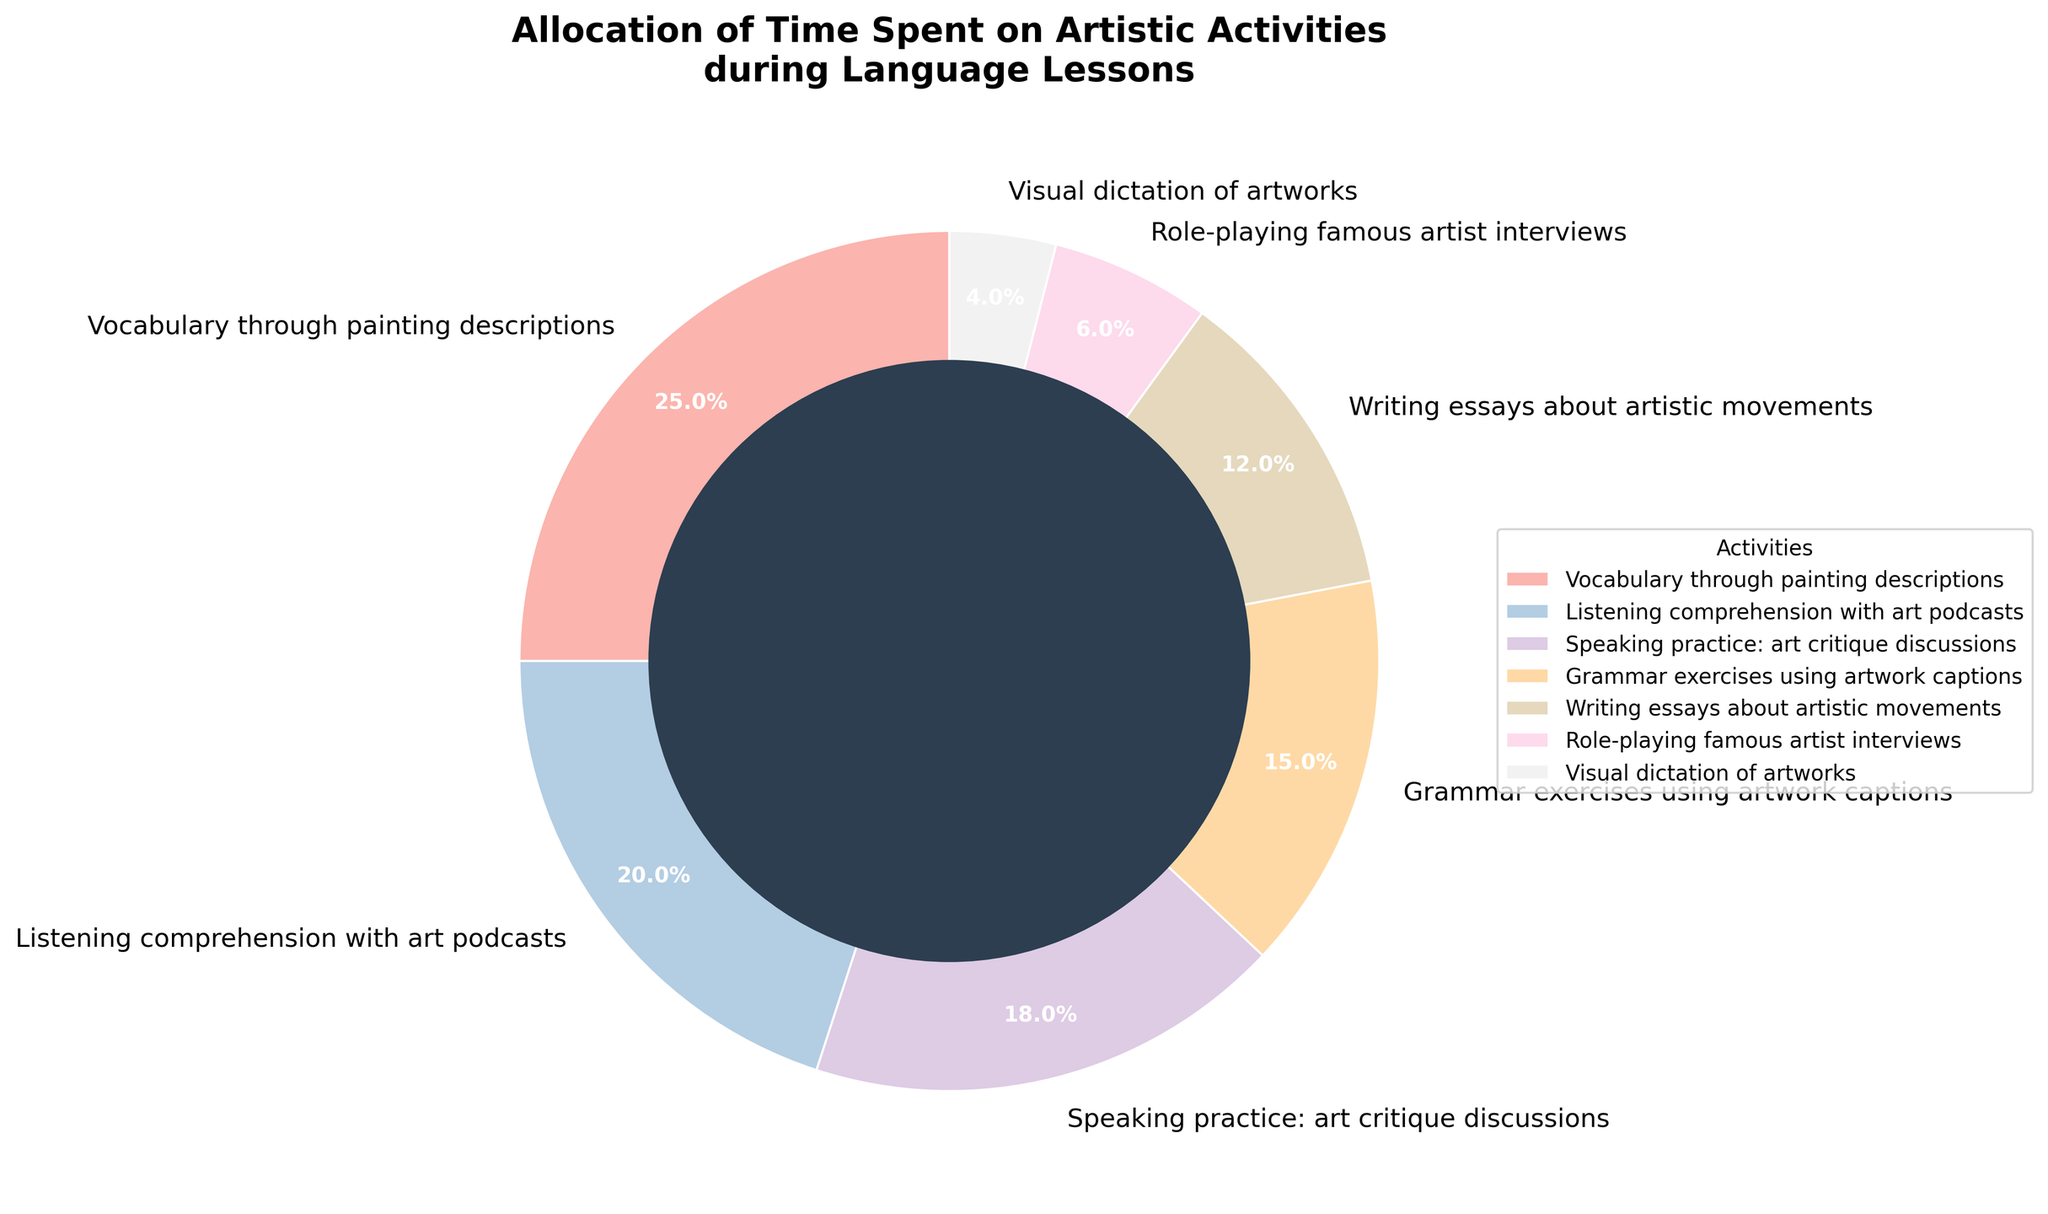What's the sum of time allocated to "Vocabulary through painting descriptions" and "Listening comprehension with art podcasts"? The time for "Vocabulary through painting descriptions" is 25%, and for "Listening comprehension with art podcasts" is 20%. Summing these two percentages: 25% + 20% = 45%
Answer: 45% Which activity has the least amount of time allocated, and what is its percentage? The activity with the smallest percentage is "Visual dictation of artworks," which has 4% time allocation as shown on the figure.
Answer: Visual dictation of artworks, 4% What is the difference in the time allocated between "Speaking practice: art critique discussions" and "Writing essays about artistic movements"? Time allocated to "Speaking practice: art critique discussions" is 18% and "Writing essays about artistic movements" is 12%. The difference is 18% - 12% = 6%.
Answer: 6% How much more time is spent on "Vocabulary through painting descriptions" compared to "Grammar exercises using artwork captions"? "Vocabulary through painting descriptions" is allocated 25%, and "Grammar exercises using artwork captions" is 15%. The difference is 25% - 15% = 10%.
Answer: 10% Which two activities combined have the highest allocation and what is their total percentage? The highest combined allocation occurs for "Vocabulary through painting descriptions" (25%) and "Listening comprehension with art podcasts" (20%). The total percentage is 25% + 20% = 45%.
Answer: Vocabulary through painting descriptions and Listening comprehension with art podcasts, 45% List the activities that have more than 15% time allocation. The activities with more than 15% time allocation are "Vocabulary through painting descriptions" (25%), "Listening comprehension with art podcasts" (20%), and "Speaking practice: art critique discussions" (18%).
Answer: Vocabulary through painting descriptions, Listening comprehension with art podcasts, Speaking practice: art critique discussions What percentage of time is allocated to activities related to "writing" (i.e., "Writing essays about artistic movements" and "Grammar exercises using artwork captions")? Time allocated to "Writing essays about artistic movements" is 12%, and for "Grammar exercises using artwork captions" is 15%. The total is 12% + 15% = 27%.
Answer: 27% What is the average percentage allocation of all activities? The percentages for all activities are: 25%, 20%, 18%, 15%, 12%, 6%, and 4%. Summing them gives 100%. There are 7 activities, so the average percentage is 100% / 7 = 14.3%.
Answer: 14.3% Is there any activity that has exactly half the time allocated compared to "Vocabulary through painting descriptions"? "Vocabulary through painting descriptions" has 25%. Half of this is 12.5%. None of the other activities have exactly this percentage.
Answer: No Which activity occupies approximately a quarter of the chart and what is its percentage? "Vocabulary through painting descriptions" occupies a significant portion of the chart, and it is allocated 25% of the time, which is approximately a quarter.
Answer: Vocabulary through painting descriptions, 25% 